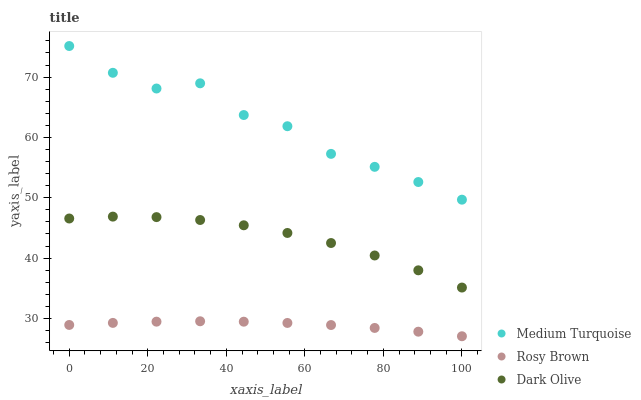Does Rosy Brown have the minimum area under the curve?
Answer yes or no. Yes. Does Medium Turquoise have the maximum area under the curve?
Answer yes or no. Yes. Does Medium Turquoise have the minimum area under the curve?
Answer yes or no. No. Does Rosy Brown have the maximum area under the curve?
Answer yes or no. No. Is Rosy Brown the smoothest?
Answer yes or no. Yes. Is Medium Turquoise the roughest?
Answer yes or no. Yes. Is Medium Turquoise the smoothest?
Answer yes or no. No. Is Rosy Brown the roughest?
Answer yes or no. No. Does Rosy Brown have the lowest value?
Answer yes or no. Yes. Does Medium Turquoise have the lowest value?
Answer yes or no. No. Does Medium Turquoise have the highest value?
Answer yes or no. Yes. Does Rosy Brown have the highest value?
Answer yes or no. No. Is Rosy Brown less than Medium Turquoise?
Answer yes or no. Yes. Is Medium Turquoise greater than Rosy Brown?
Answer yes or no. Yes. Does Rosy Brown intersect Medium Turquoise?
Answer yes or no. No. 